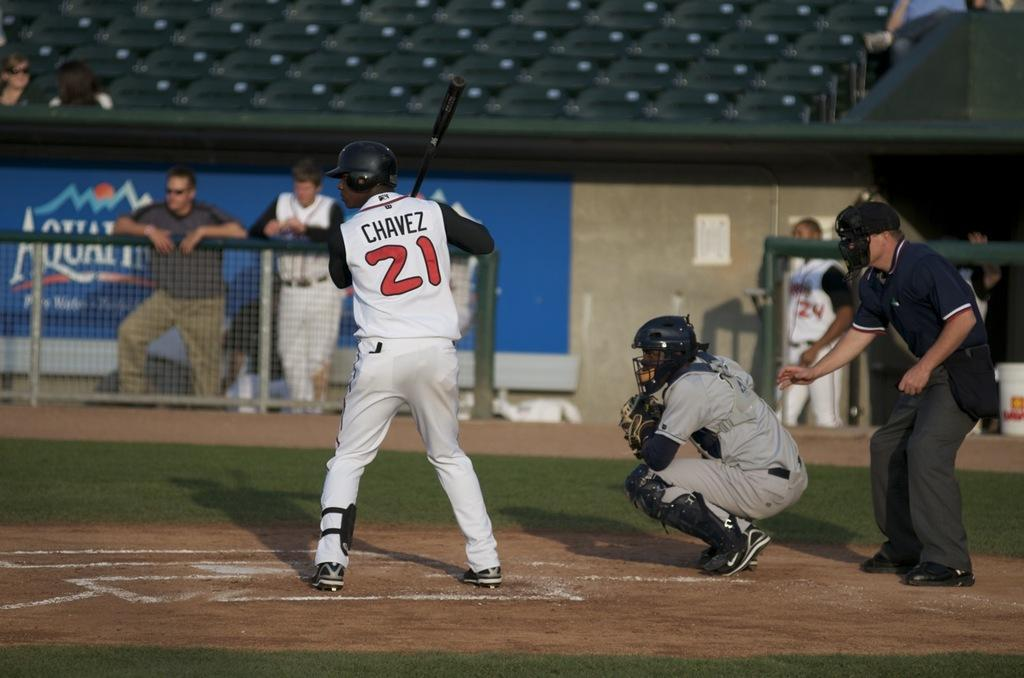<image>
Render a clear and concise summary of the photo. A baseball player named Chavez is up to bat. 